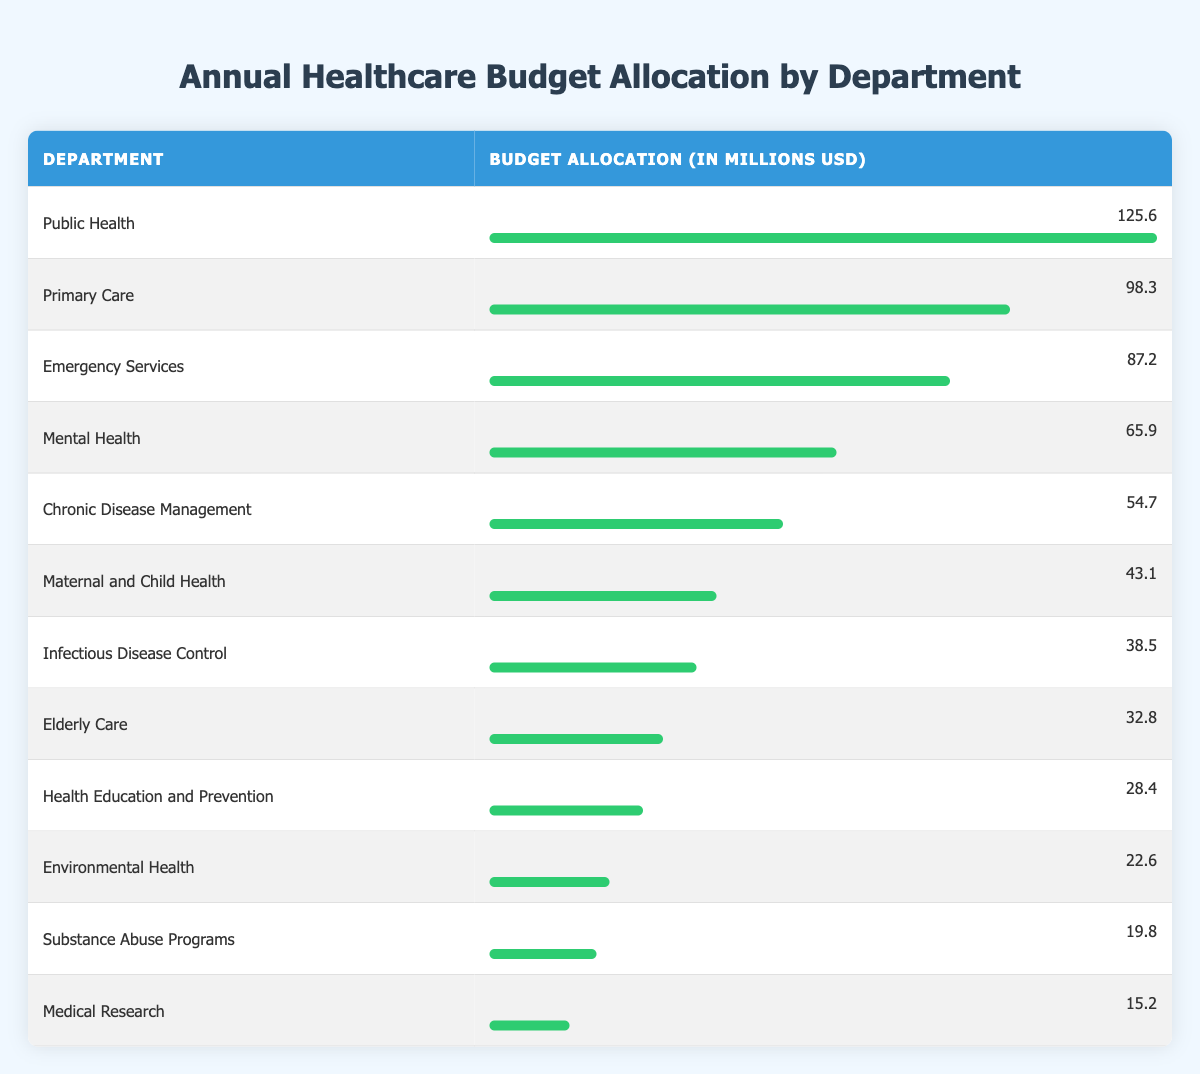What department has the highest budget allocation? The table shows the budget allocation for each department, and by comparing the values, Public Health has the highest allocation at 125.6 million USD.
Answer: Public Health What is the budget allocation for Mental Health? In the table, the budget allocation for Mental Health is listed as 65.9 million USD.
Answer: 65.9 million USD How much is allocated to Chronic Disease Management compared to Emergency Services? The table shows Chronic Disease Management with 54.7 million USD and Emergency Services with 87.2 million USD. The comparison shows that Emergency Services has a higher allocation by 32.5 million USD (87.2 - 54.7 = 32.5).
Answer: 32.5 million USD Is the total budget allocation for Infectious Disease Control and Elderly Care more than 70 million USD? The budget allocation for Infectious Disease Control is 38.5 million USD, and for Elderly Care, it is 32.8 million USD. Adding these values gives a total of 71.3 million USD (38.5 + 32.8 = 71.3), which is more than 70 million USD.
Answer: Yes What is the average budget allocation across all departments? To find the average, first sum the budget allocations: 125.6 + 98.3 + 87.2 + 65.9 + 54.7 + 43.1 + 38.5 + 32.8 + 28.4 + 22.6 + 19.8 + 15.2 =  649.1 million USD. There are 12 departments, so dividing the total by the number of departments gives an average of 54.09 million USD (649.1 / 12 = 54.09).
Answer: 54.09 million USD 